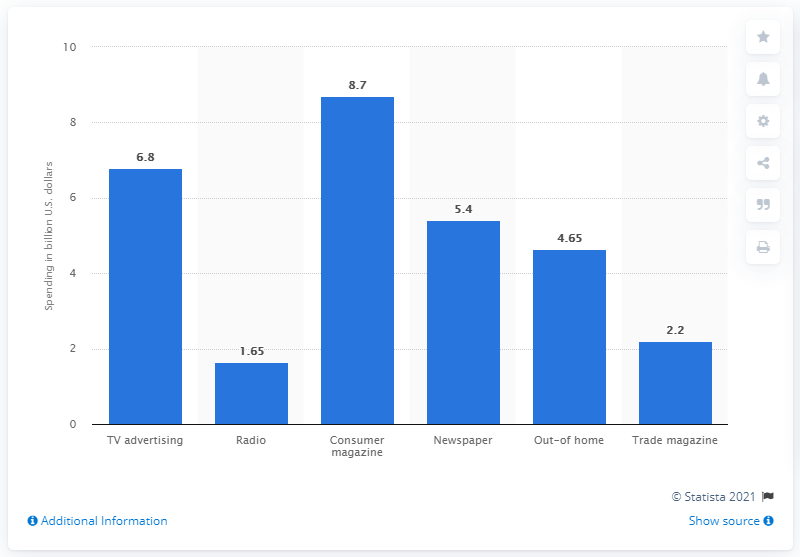Draw attention to some important aspects in this diagram. In 2019, the estimated amount of digital newspaper ad spending in the United States was approximately $5.4 million. 